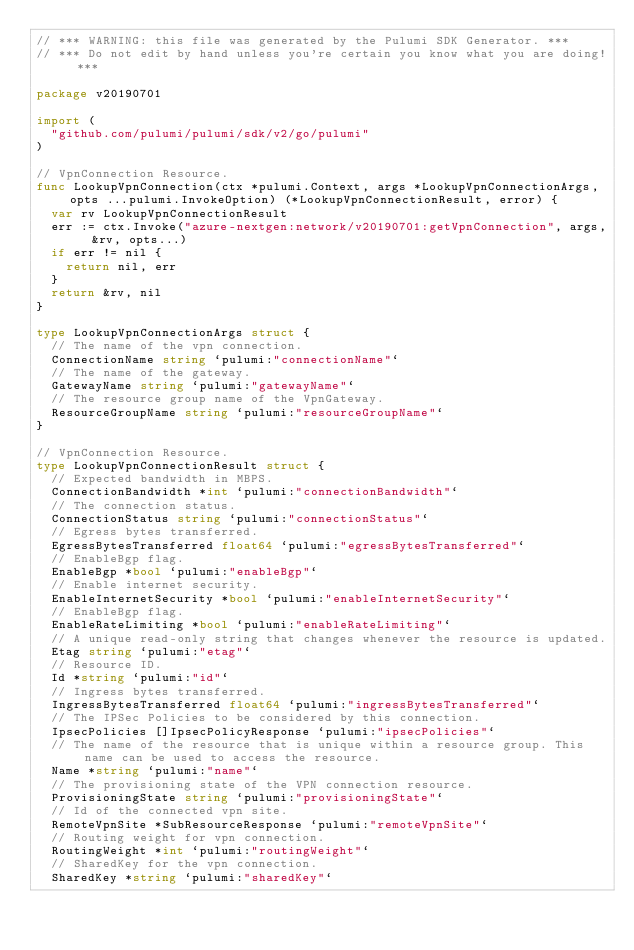Convert code to text. <code><loc_0><loc_0><loc_500><loc_500><_Go_>// *** WARNING: this file was generated by the Pulumi SDK Generator. ***
// *** Do not edit by hand unless you're certain you know what you are doing! ***

package v20190701

import (
	"github.com/pulumi/pulumi/sdk/v2/go/pulumi"
)

// VpnConnection Resource.
func LookupVpnConnection(ctx *pulumi.Context, args *LookupVpnConnectionArgs, opts ...pulumi.InvokeOption) (*LookupVpnConnectionResult, error) {
	var rv LookupVpnConnectionResult
	err := ctx.Invoke("azure-nextgen:network/v20190701:getVpnConnection", args, &rv, opts...)
	if err != nil {
		return nil, err
	}
	return &rv, nil
}

type LookupVpnConnectionArgs struct {
	// The name of the vpn connection.
	ConnectionName string `pulumi:"connectionName"`
	// The name of the gateway.
	GatewayName string `pulumi:"gatewayName"`
	// The resource group name of the VpnGateway.
	ResourceGroupName string `pulumi:"resourceGroupName"`
}

// VpnConnection Resource.
type LookupVpnConnectionResult struct {
	// Expected bandwidth in MBPS.
	ConnectionBandwidth *int `pulumi:"connectionBandwidth"`
	// The connection status.
	ConnectionStatus string `pulumi:"connectionStatus"`
	// Egress bytes transferred.
	EgressBytesTransferred float64 `pulumi:"egressBytesTransferred"`
	// EnableBgp flag.
	EnableBgp *bool `pulumi:"enableBgp"`
	// Enable internet security.
	EnableInternetSecurity *bool `pulumi:"enableInternetSecurity"`
	// EnableBgp flag.
	EnableRateLimiting *bool `pulumi:"enableRateLimiting"`
	// A unique read-only string that changes whenever the resource is updated.
	Etag string `pulumi:"etag"`
	// Resource ID.
	Id *string `pulumi:"id"`
	// Ingress bytes transferred.
	IngressBytesTransferred float64 `pulumi:"ingressBytesTransferred"`
	// The IPSec Policies to be considered by this connection.
	IpsecPolicies []IpsecPolicyResponse `pulumi:"ipsecPolicies"`
	// The name of the resource that is unique within a resource group. This name can be used to access the resource.
	Name *string `pulumi:"name"`
	// The provisioning state of the VPN connection resource.
	ProvisioningState string `pulumi:"provisioningState"`
	// Id of the connected vpn site.
	RemoteVpnSite *SubResourceResponse `pulumi:"remoteVpnSite"`
	// Routing weight for vpn connection.
	RoutingWeight *int `pulumi:"routingWeight"`
	// SharedKey for the vpn connection.
	SharedKey *string `pulumi:"sharedKey"`</code> 